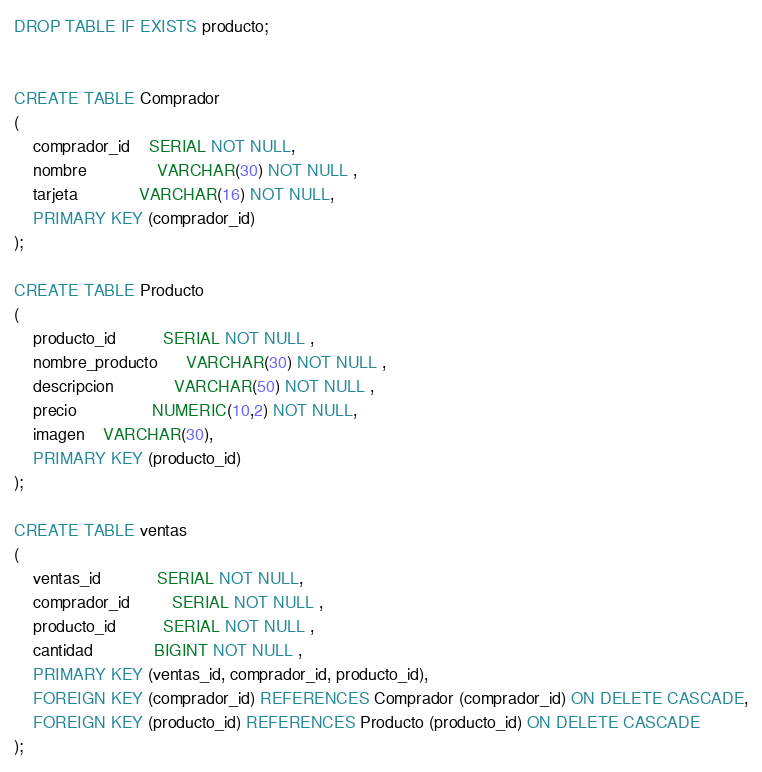Convert code to text. <code><loc_0><loc_0><loc_500><loc_500><_SQL_>DROP TABLE IF EXISTS producto;


CREATE TABLE Comprador
(
	comprador_id	SERIAL NOT NULL,
	nombre               VARCHAR(30) NOT NULL ,
	tarjeta		     VARCHAR(16) NOT NULL,
	PRIMARY KEY (comprador_id)
);

CREATE TABLE Producto
(
	producto_id          SERIAL NOT NULL ,
	nombre_producto      VARCHAR(30) NOT NULL ,
	descripcion			 VARCHAR(50) NOT NULL ,
	precio				NUMERIC(10,2) NOT NULL,
	imagen 	VARCHAR(30),
	PRIMARY KEY (producto_id)
);

CREATE TABLE ventas
(
	ventas_id			SERIAL NOT NULL,
	comprador_id         SERIAL NOT NULL ,
	producto_id          SERIAL NOT NULL ,
	cantidad             BIGINT NOT NULL ,
	PRIMARY KEY (ventas_id, comprador_id, producto_id),
	FOREIGN KEY (comprador_id) REFERENCES Comprador (comprador_id) ON DELETE CASCADE,
	FOREIGN KEY (producto_id) REFERENCES Producto (producto_id) ON DELETE CASCADE
);</code> 